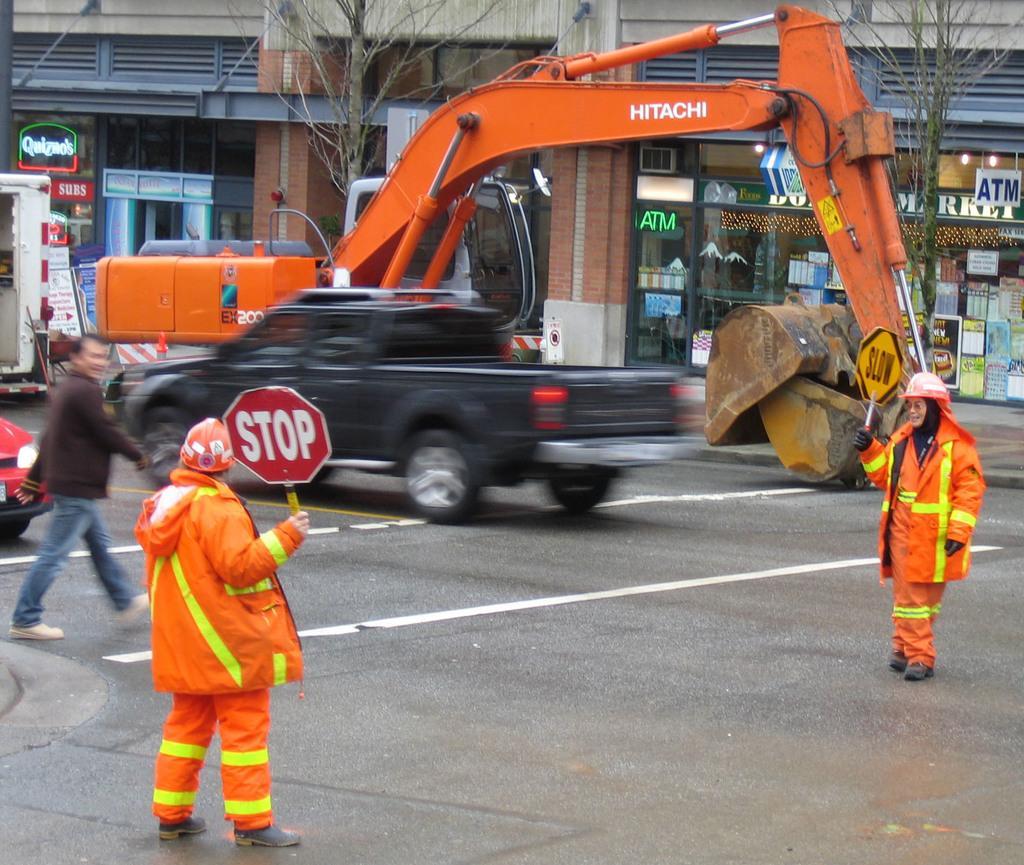Can you describe this image briefly? In this image I can see the vehicles and few people are on the road. I can see two persons holding the boards. In the background I can see the trees and the buildings with boards. 